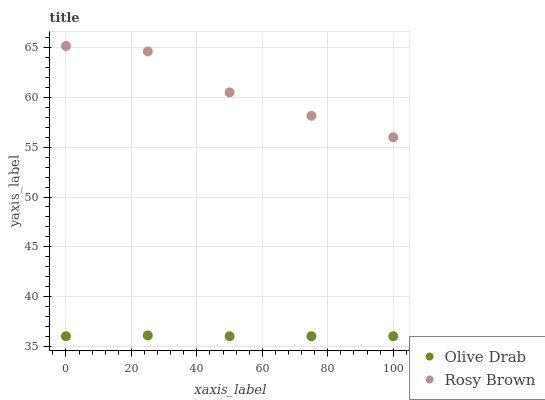Does Olive Drab have the minimum area under the curve?
Answer yes or no. Yes. Does Rosy Brown have the maximum area under the curve?
Answer yes or no. Yes. Does Olive Drab have the maximum area under the curve?
Answer yes or no. No. Is Olive Drab the smoothest?
Answer yes or no. Yes. Is Rosy Brown the roughest?
Answer yes or no. Yes. Is Olive Drab the roughest?
Answer yes or no. No. Does Olive Drab have the lowest value?
Answer yes or no. Yes. Does Rosy Brown have the highest value?
Answer yes or no. Yes. Does Olive Drab have the highest value?
Answer yes or no. No. Is Olive Drab less than Rosy Brown?
Answer yes or no. Yes. Is Rosy Brown greater than Olive Drab?
Answer yes or no. Yes. Does Olive Drab intersect Rosy Brown?
Answer yes or no. No. 